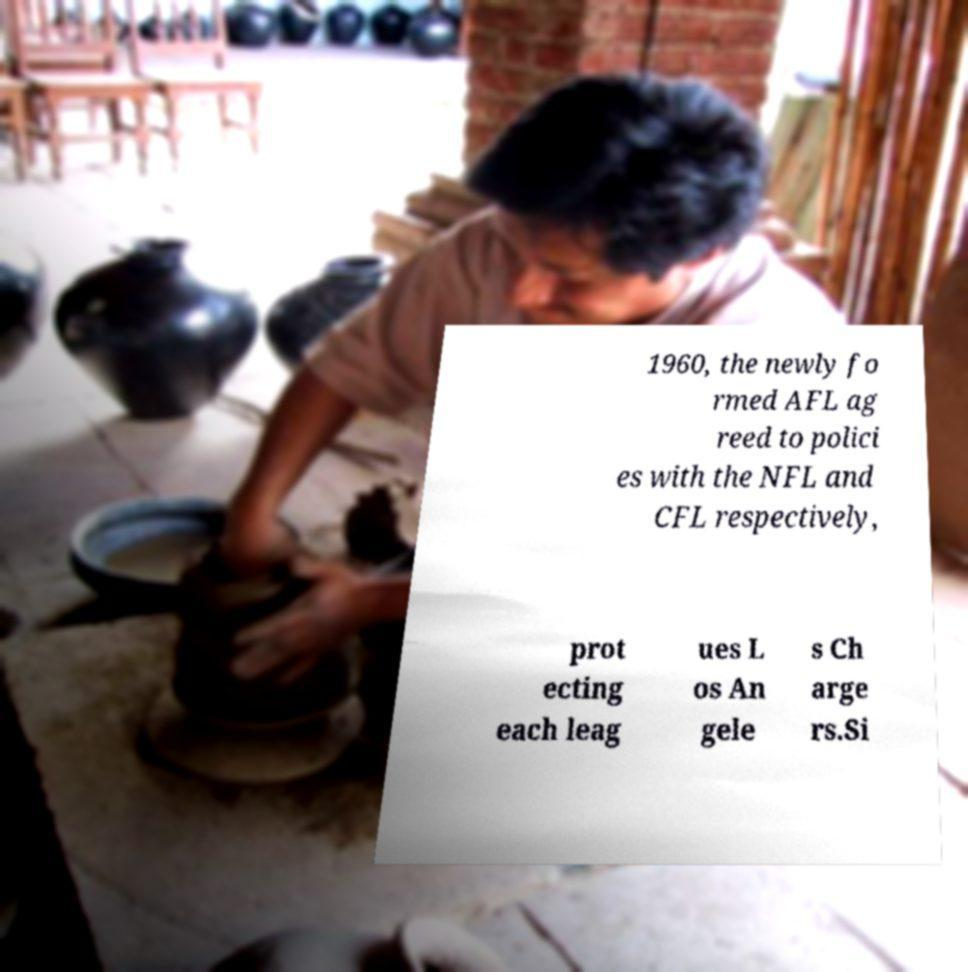I need the written content from this picture converted into text. Can you do that? 1960, the newly fo rmed AFL ag reed to polici es with the NFL and CFL respectively, prot ecting each leag ues L os An gele s Ch arge rs.Si 